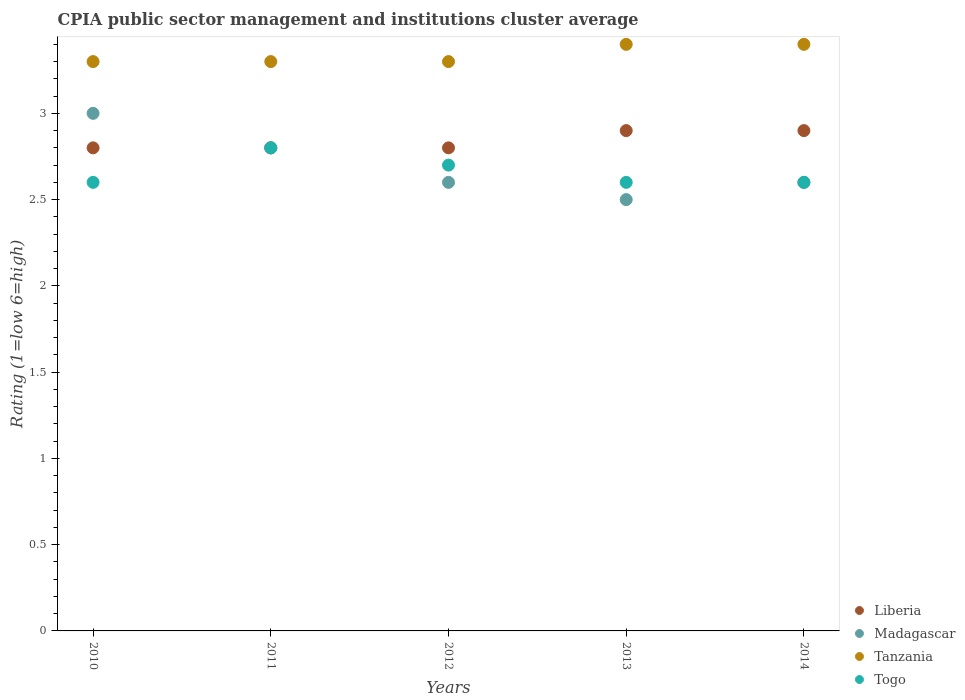Is the number of dotlines equal to the number of legend labels?
Provide a succinct answer. Yes. What is the CPIA rating in Tanzania in 2014?
Give a very brief answer. 3.4. Across all years, what is the maximum CPIA rating in Liberia?
Offer a very short reply. 2.9. In which year was the CPIA rating in Liberia maximum?
Offer a terse response. 2013. What is the difference between the CPIA rating in Madagascar in 2012 and that in 2013?
Offer a very short reply. 0.1. What is the difference between the CPIA rating in Togo in 2011 and the CPIA rating in Liberia in 2013?
Give a very brief answer. -0.1. What is the average CPIA rating in Madagascar per year?
Keep it short and to the point. 2.7. In the year 2011, what is the difference between the CPIA rating in Liberia and CPIA rating in Madagascar?
Your response must be concise. 0. What is the ratio of the CPIA rating in Togo in 2010 to that in 2011?
Give a very brief answer. 0.93. What is the difference between the highest and the lowest CPIA rating in Tanzania?
Provide a succinct answer. 0.1. Is it the case that in every year, the sum of the CPIA rating in Tanzania and CPIA rating in Liberia  is greater than the CPIA rating in Madagascar?
Your answer should be compact. Yes. Is the CPIA rating in Liberia strictly less than the CPIA rating in Tanzania over the years?
Make the answer very short. Yes. How many years are there in the graph?
Ensure brevity in your answer.  5. What is the difference between two consecutive major ticks on the Y-axis?
Your answer should be very brief. 0.5. Are the values on the major ticks of Y-axis written in scientific E-notation?
Ensure brevity in your answer.  No. Does the graph contain grids?
Give a very brief answer. No. How are the legend labels stacked?
Make the answer very short. Vertical. What is the title of the graph?
Ensure brevity in your answer.  CPIA public sector management and institutions cluster average. What is the Rating (1=low 6=high) of Madagascar in 2010?
Keep it short and to the point. 3. What is the Rating (1=low 6=high) of Madagascar in 2011?
Ensure brevity in your answer.  2.8. What is the Rating (1=low 6=high) of Tanzania in 2012?
Offer a very short reply. 3.3. What is the Rating (1=low 6=high) of Togo in 2012?
Your response must be concise. 2.7. What is the Rating (1=low 6=high) in Liberia in 2013?
Provide a succinct answer. 2.9. What is the Rating (1=low 6=high) of Tanzania in 2013?
Your answer should be compact. 3.4. What is the Rating (1=low 6=high) of Tanzania in 2014?
Your response must be concise. 3.4. What is the Rating (1=low 6=high) of Togo in 2014?
Keep it short and to the point. 2.6. Across all years, what is the maximum Rating (1=low 6=high) in Liberia?
Keep it short and to the point. 2.9. Across all years, what is the minimum Rating (1=low 6=high) in Liberia?
Your answer should be very brief. 2.8. Across all years, what is the minimum Rating (1=low 6=high) in Madagascar?
Offer a very short reply. 2.5. Across all years, what is the minimum Rating (1=low 6=high) in Tanzania?
Keep it short and to the point. 3.3. What is the total Rating (1=low 6=high) of Liberia in the graph?
Provide a succinct answer. 14.2. What is the difference between the Rating (1=low 6=high) of Liberia in 2010 and that in 2011?
Provide a succinct answer. 0. What is the difference between the Rating (1=low 6=high) of Tanzania in 2010 and that in 2011?
Your answer should be very brief. 0. What is the difference between the Rating (1=low 6=high) in Madagascar in 2010 and that in 2012?
Provide a succinct answer. 0.4. What is the difference between the Rating (1=low 6=high) in Tanzania in 2010 and that in 2012?
Your answer should be very brief. 0. What is the difference between the Rating (1=low 6=high) of Togo in 2010 and that in 2012?
Your answer should be very brief. -0.1. What is the difference between the Rating (1=low 6=high) in Tanzania in 2010 and that in 2013?
Your response must be concise. -0.1. What is the difference between the Rating (1=low 6=high) of Togo in 2010 and that in 2013?
Offer a terse response. 0. What is the difference between the Rating (1=low 6=high) in Liberia in 2011 and that in 2012?
Your answer should be compact. 0. What is the difference between the Rating (1=low 6=high) in Madagascar in 2011 and that in 2012?
Your response must be concise. 0.2. What is the difference between the Rating (1=low 6=high) in Tanzania in 2011 and that in 2012?
Offer a terse response. 0. What is the difference between the Rating (1=low 6=high) of Liberia in 2011 and that in 2013?
Give a very brief answer. -0.1. What is the difference between the Rating (1=low 6=high) of Liberia in 2011 and that in 2014?
Your answer should be very brief. -0.1. What is the difference between the Rating (1=low 6=high) of Togo in 2011 and that in 2014?
Keep it short and to the point. 0.2. What is the difference between the Rating (1=low 6=high) in Tanzania in 2012 and that in 2013?
Provide a short and direct response. -0.1. What is the difference between the Rating (1=low 6=high) in Togo in 2012 and that in 2013?
Ensure brevity in your answer.  0.1. What is the difference between the Rating (1=low 6=high) in Liberia in 2012 and that in 2014?
Make the answer very short. -0.1. What is the difference between the Rating (1=low 6=high) in Tanzania in 2012 and that in 2014?
Your answer should be compact. -0.1. What is the difference between the Rating (1=low 6=high) of Liberia in 2013 and that in 2014?
Your answer should be compact. 0. What is the difference between the Rating (1=low 6=high) in Madagascar in 2013 and that in 2014?
Offer a very short reply. -0.1. What is the difference between the Rating (1=low 6=high) in Liberia in 2010 and the Rating (1=low 6=high) in Madagascar in 2011?
Keep it short and to the point. 0. What is the difference between the Rating (1=low 6=high) in Liberia in 2010 and the Rating (1=low 6=high) in Tanzania in 2011?
Ensure brevity in your answer.  -0.5. What is the difference between the Rating (1=low 6=high) of Liberia in 2010 and the Rating (1=low 6=high) of Togo in 2011?
Your answer should be very brief. 0. What is the difference between the Rating (1=low 6=high) in Madagascar in 2010 and the Rating (1=low 6=high) in Tanzania in 2011?
Offer a terse response. -0.3. What is the difference between the Rating (1=low 6=high) in Madagascar in 2010 and the Rating (1=low 6=high) in Togo in 2011?
Your answer should be compact. 0.2. What is the difference between the Rating (1=low 6=high) of Liberia in 2010 and the Rating (1=low 6=high) of Madagascar in 2012?
Offer a very short reply. 0.2. What is the difference between the Rating (1=low 6=high) of Liberia in 2010 and the Rating (1=low 6=high) of Tanzania in 2012?
Give a very brief answer. -0.5. What is the difference between the Rating (1=low 6=high) of Liberia in 2010 and the Rating (1=low 6=high) of Togo in 2012?
Your answer should be very brief. 0.1. What is the difference between the Rating (1=low 6=high) of Madagascar in 2010 and the Rating (1=low 6=high) of Tanzania in 2012?
Offer a very short reply. -0.3. What is the difference between the Rating (1=low 6=high) in Madagascar in 2010 and the Rating (1=low 6=high) in Togo in 2012?
Provide a succinct answer. 0.3. What is the difference between the Rating (1=low 6=high) in Tanzania in 2010 and the Rating (1=low 6=high) in Togo in 2012?
Ensure brevity in your answer.  0.6. What is the difference between the Rating (1=low 6=high) of Liberia in 2010 and the Rating (1=low 6=high) of Madagascar in 2013?
Give a very brief answer. 0.3. What is the difference between the Rating (1=low 6=high) in Liberia in 2010 and the Rating (1=low 6=high) in Togo in 2013?
Your answer should be compact. 0.2. What is the difference between the Rating (1=low 6=high) of Madagascar in 2010 and the Rating (1=low 6=high) of Tanzania in 2013?
Offer a very short reply. -0.4. What is the difference between the Rating (1=low 6=high) in Liberia in 2010 and the Rating (1=low 6=high) in Madagascar in 2014?
Give a very brief answer. 0.2. What is the difference between the Rating (1=low 6=high) of Liberia in 2010 and the Rating (1=low 6=high) of Togo in 2014?
Offer a terse response. 0.2. What is the difference between the Rating (1=low 6=high) in Madagascar in 2010 and the Rating (1=low 6=high) in Tanzania in 2014?
Ensure brevity in your answer.  -0.4. What is the difference between the Rating (1=low 6=high) in Madagascar in 2011 and the Rating (1=low 6=high) in Togo in 2012?
Offer a very short reply. 0.1. What is the difference between the Rating (1=low 6=high) of Liberia in 2011 and the Rating (1=low 6=high) of Tanzania in 2013?
Your response must be concise. -0.6. What is the difference between the Rating (1=low 6=high) in Liberia in 2011 and the Rating (1=low 6=high) in Togo in 2013?
Provide a short and direct response. 0.2. What is the difference between the Rating (1=low 6=high) in Madagascar in 2011 and the Rating (1=low 6=high) in Tanzania in 2013?
Make the answer very short. -0.6. What is the difference between the Rating (1=low 6=high) in Tanzania in 2011 and the Rating (1=low 6=high) in Togo in 2013?
Provide a succinct answer. 0.7. What is the difference between the Rating (1=low 6=high) of Liberia in 2011 and the Rating (1=low 6=high) of Madagascar in 2014?
Your response must be concise. 0.2. What is the difference between the Rating (1=low 6=high) in Liberia in 2011 and the Rating (1=low 6=high) in Togo in 2014?
Make the answer very short. 0.2. What is the difference between the Rating (1=low 6=high) of Madagascar in 2011 and the Rating (1=low 6=high) of Tanzania in 2014?
Provide a short and direct response. -0.6. What is the difference between the Rating (1=low 6=high) of Madagascar in 2011 and the Rating (1=low 6=high) of Togo in 2014?
Your answer should be compact. 0.2. What is the difference between the Rating (1=low 6=high) of Madagascar in 2012 and the Rating (1=low 6=high) of Tanzania in 2013?
Ensure brevity in your answer.  -0.8. What is the difference between the Rating (1=low 6=high) in Tanzania in 2012 and the Rating (1=low 6=high) in Togo in 2013?
Keep it short and to the point. 0.7. What is the difference between the Rating (1=low 6=high) of Liberia in 2012 and the Rating (1=low 6=high) of Madagascar in 2014?
Ensure brevity in your answer.  0.2. What is the difference between the Rating (1=low 6=high) in Liberia in 2012 and the Rating (1=low 6=high) in Tanzania in 2014?
Your response must be concise. -0.6. What is the difference between the Rating (1=low 6=high) in Liberia in 2012 and the Rating (1=low 6=high) in Togo in 2014?
Provide a succinct answer. 0.2. What is the difference between the Rating (1=low 6=high) of Tanzania in 2012 and the Rating (1=low 6=high) of Togo in 2014?
Provide a succinct answer. 0.7. What is the difference between the Rating (1=low 6=high) in Liberia in 2013 and the Rating (1=low 6=high) in Madagascar in 2014?
Give a very brief answer. 0.3. What is the difference between the Rating (1=low 6=high) in Liberia in 2013 and the Rating (1=low 6=high) in Tanzania in 2014?
Provide a succinct answer. -0.5. What is the difference between the Rating (1=low 6=high) of Liberia in 2013 and the Rating (1=low 6=high) of Togo in 2014?
Your answer should be compact. 0.3. What is the average Rating (1=low 6=high) of Liberia per year?
Your answer should be compact. 2.84. What is the average Rating (1=low 6=high) of Tanzania per year?
Your answer should be very brief. 3.34. What is the average Rating (1=low 6=high) of Togo per year?
Ensure brevity in your answer.  2.66. In the year 2010, what is the difference between the Rating (1=low 6=high) of Liberia and Rating (1=low 6=high) of Madagascar?
Keep it short and to the point. -0.2. In the year 2010, what is the difference between the Rating (1=low 6=high) of Liberia and Rating (1=low 6=high) of Tanzania?
Make the answer very short. -0.5. In the year 2010, what is the difference between the Rating (1=low 6=high) of Liberia and Rating (1=low 6=high) of Togo?
Give a very brief answer. 0.2. In the year 2010, what is the difference between the Rating (1=low 6=high) of Madagascar and Rating (1=low 6=high) of Togo?
Give a very brief answer. 0.4. In the year 2010, what is the difference between the Rating (1=low 6=high) in Tanzania and Rating (1=low 6=high) in Togo?
Keep it short and to the point. 0.7. In the year 2011, what is the difference between the Rating (1=low 6=high) in Liberia and Rating (1=low 6=high) in Togo?
Give a very brief answer. 0. In the year 2011, what is the difference between the Rating (1=low 6=high) of Madagascar and Rating (1=low 6=high) of Togo?
Your answer should be compact. 0. In the year 2011, what is the difference between the Rating (1=low 6=high) of Tanzania and Rating (1=low 6=high) of Togo?
Offer a very short reply. 0.5. In the year 2012, what is the difference between the Rating (1=low 6=high) of Liberia and Rating (1=low 6=high) of Madagascar?
Offer a very short reply. 0.2. In the year 2012, what is the difference between the Rating (1=low 6=high) of Madagascar and Rating (1=low 6=high) of Tanzania?
Offer a very short reply. -0.7. In the year 2012, what is the difference between the Rating (1=low 6=high) in Tanzania and Rating (1=low 6=high) in Togo?
Give a very brief answer. 0.6. In the year 2013, what is the difference between the Rating (1=low 6=high) in Liberia and Rating (1=low 6=high) in Madagascar?
Provide a succinct answer. 0.4. In the year 2013, what is the difference between the Rating (1=low 6=high) in Madagascar and Rating (1=low 6=high) in Tanzania?
Your answer should be compact. -0.9. In the year 2013, what is the difference between the Rating (1=low 6=high) of Tanzania and Rating (1=low 6=high) of Togo?
Keep it short and to the point. 0.8. In the year 2014, what is the difference between the Rating (1=low 6=high) of Liberia and Rating (1=low 6=high) of Madagascar?
Your response must be concise. 0.3. In the year 2014, what is the difference between the Rating (1=low 6=high) in Madagascar and Rating (1=low 6=high) in Togo?
Your answer should be compact. 0. In the year 2014, what is the difference between the Rating (1=low 6=high) in Tanzania and Rating (1=low 6=high) in Togo?
Keep it short and to the point. 0.8. What is the ratio of the Rating (1=low 6=high) in Madagascar in 2010 to that in 2011?
Provide a short and direct response. 1.07. What is the ratio of the Rating (1=low 6=high) of Tanzania in 2010 to that in 2011?
Ensure brevity in your answer.  1. What is the ratio of the Rating (1=low 6=high) of Liberia in 2010 to that in 2012?
Your answer should be very brief. 1. What is the ratio of the Rating (1=low 6=high) in Madagascar in 2010 to that in 2012?
Make the answer very short. 1.15. What is the ratio of the Rating (1=low 6=high) in Togo in 2010 to that in 2012?
Your response must be concise. 0.96. What is the ratio of the Rating (1=low 6=high) of Liberia in 2010 to that in 2013?
Keep it short and to the point. 0.97. What is the ratio of the Rating (1=low 6=high) of Tanzania in 2010 to that in 2013?
Your answer should be very brief. 0.97. What is the ratio of the Rating (1=low 6=high) in Liberia in 2010 to that in 2014?
Offer a very short reply. 0.97. What is the ratio of the Rating (1=low 6=high) in Madagascar in 2010 to that in 2014?
Your response must be concise. 1.15. What is the ratio of the Rating (1=low 6=high) of Tanzania in 2010 to that in 2014?
Offer a very short reply. 0.97. What is the ratio of the Rating (1=low 6=high) of Togo in 2010 to that in 2014?
Your answer should be compact. 1. What is the ratio of the Rating (1=low 6=high) in Liberia in 2011 to that in 2012?
Offer a very short reply. 1. What is the ratio of the Rating (1=low 6=high) in Madagascar in 2011 to that in 2012?
Your answer should be very brief. 1.08. What is the ratio of the Rating (1=low 6=high) of Togo in 2011 to that in 2012?
Your answer should be very brief. 1.04. What is the ratio of the Rating (1=low 6=high) of Liberia in 2011 to that in 2013?
Make the answer very short. 0.97. What is the ratio of the Rating (1=low 6=high) of Madagascar in 2011 to that in 2013?
Your answer should be very brief. 1.12. What is the ratio of the Rating (1=low 6=high) of Tanzania in 2011 to that in 2013?
Ensure brevity in your answer.  0.97. What is the ratio of the Rating (1=low 6=high) in Togo in 2011 to that in 2013?
Offer a terse response. 1.08. What is the ratio of the Rating (1=low 6=high) in Liberia in 2011 to that in 2014?
Offer a very short reply. 0.97. What is the ratio of the Rating (1=low 6=high) of Tanzania in 2011 to that in 2014?
Your answer should be very brief. 0.97. What is the ratio of the Rating (1=low 6=high) of Togo in 2011 to that in 2014?
Make the answer very short. 1.08. What is the ratio of the Rating (1=low 6=high) of Liberia in 2012 to that in 2013?
Your answer should be compact. 0.97. What is the ratio of the Rating (1=low 6=high) in Tanzania in 2012 to that in 2013?
Give a very brief answer. 0.97. What is the ratio of the Rating (1=low 6=high) of Liberia in 2012 to that in 2014?
Your answer should be compact. 0.97. What is the ratio of the Rating (1=low 6=high) of Madagascar in 2012 to that in 2014?
Provide a succinct answer. 1. What is the ratio of the Rating (1=low 6=high) in Tanzania in 2012 to that in 2014?
Your answer should be compact. 0.97. What is the ratio of the Rating (1=low 6=high) of Liberia in 2013 to that in 2014?
Ensure brevity in your answer.  1. What is the ratio of the Rating (1=low 6=high) of Madagascar in 2013 to that in 2014?
Make the answer very short. 0.96. What is the ratio of the Rating (1=low 6=high) in Tanzania in 2013 to that in 2014?
Make the answer very short. 1. What is the difference between the highest and the lowest Rating (1=low 6=high) of Liberia?
Make the answer very short. 0.1. What is the difference between the highest and the lowest Rating (1=low 6=high) in Tanzania?
Make the answer very short. 0.1. What is the difference between the highest and the lowest Rating (1=low 6=high) in Togo?
Your answer should be very brief. 0.2. 